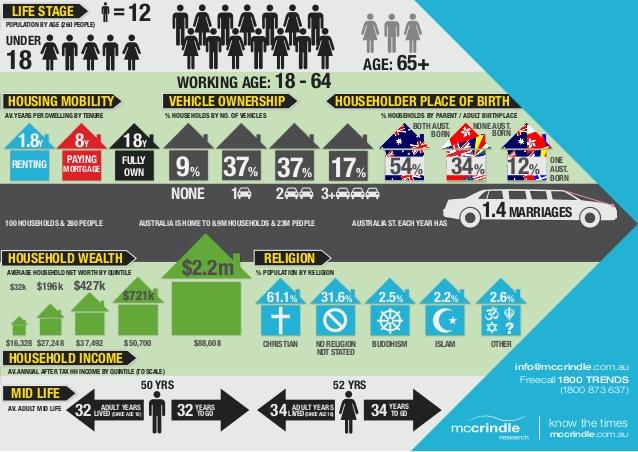Draw attention to some important aspects in this diagram. The average age of mid-life for adult female is 52. According to the data, approximately 17% of households own three or more vehicles. According to the data, 91% of households own one or more vehicles. According to the data, 38.9% of the population do not follow Christianity. The average adult mid-life age for males is 50 years. 